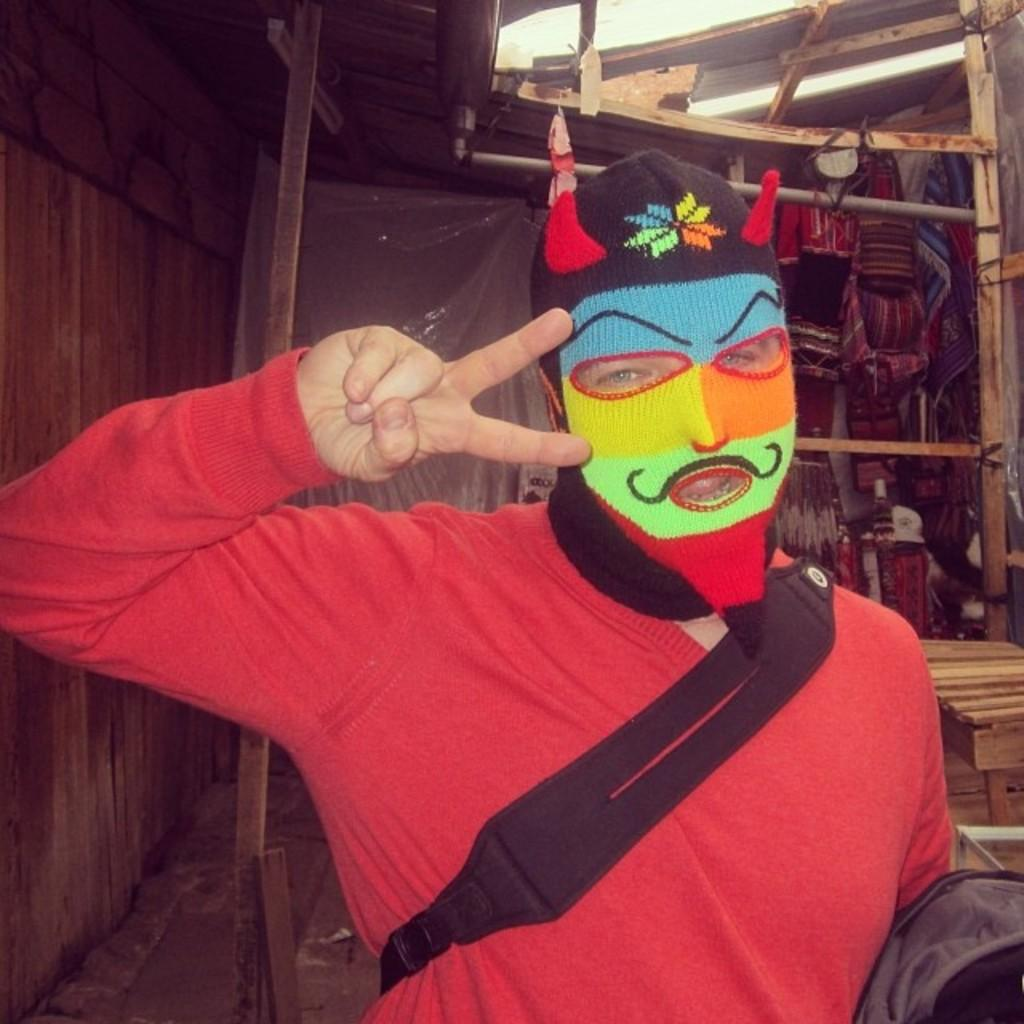What is the main subject of the image? There is a person standing in the center of the image. What can be seen in the background of the image? There is a wall and wooden sticks in the background of the image. What type of ice can be seen melting on the person's head in the image? There is no ice present on the person's head in the image. What activity is the person participating in at the camp in the image? There is no camp or activity mentioned in the image; it only shows a person standing with a wall and wooden sticks in the background. 